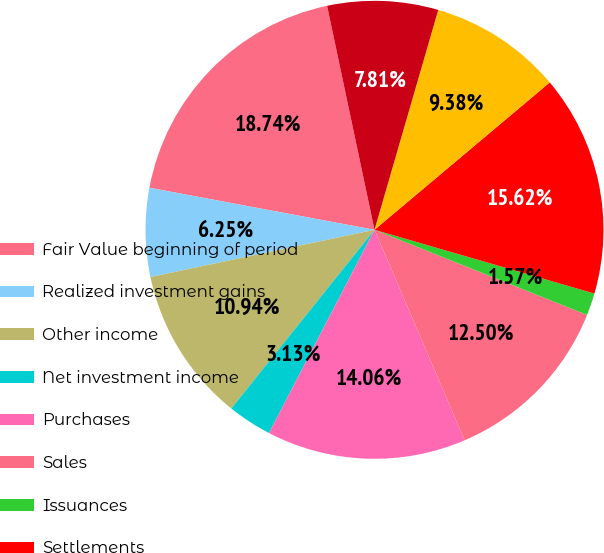<chart> <loc_0><loc_0><loc_500><loc_500><pie_chart><fcel>Fair Value beginning of period<fcel>Realized investment gains<fcel>Other income<fcel>Net investment income<fcel>Purchases<fcel>Sales<fcel>Issuances<fcel>Settlements<fcel>Foreign currency translation<fcel>Other(1)<nl><fcel>18.74%<fcel>6.25%<fcel>10.94%<fcel>3.13%<fcel>14.06%<fcel>12.5%<fcel>1.57%<fcel>15.62%<fcel>9.38%<fcel>7.81%<nl></chart> 